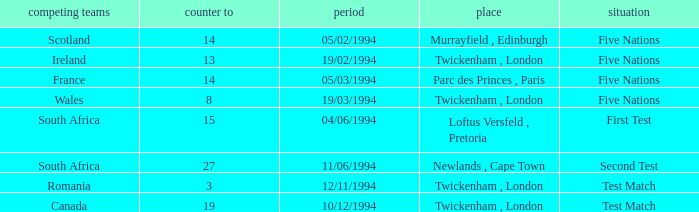Which venue has more than 19 against? Newlands , Cape Town. 